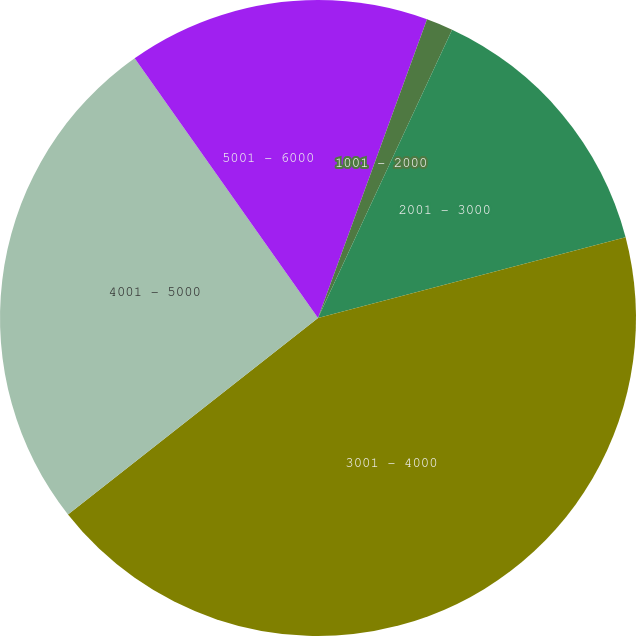Convert chart. <chart><loc_0><loc_0><loc_500><loc_500><pie_chart><fcel>501 - 1000<fcel>1001 - 2000<fcel>2001 - 3000<fcel>3001 - 4000<fcel>4001 - 5000<fcel>5001 - 6000<nl><fcel>5.57%<fcel>1.36%<fcel>13.99%<fcel>43.48%<fcel>25.82%<fcel>9.78%<nl></chart> 